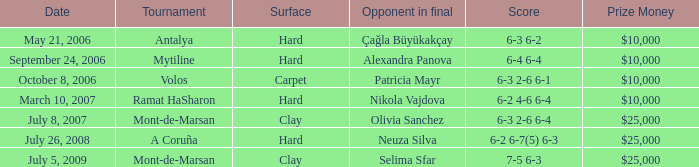Who was the opponent on carpet in a final? Patricia Mayr. 